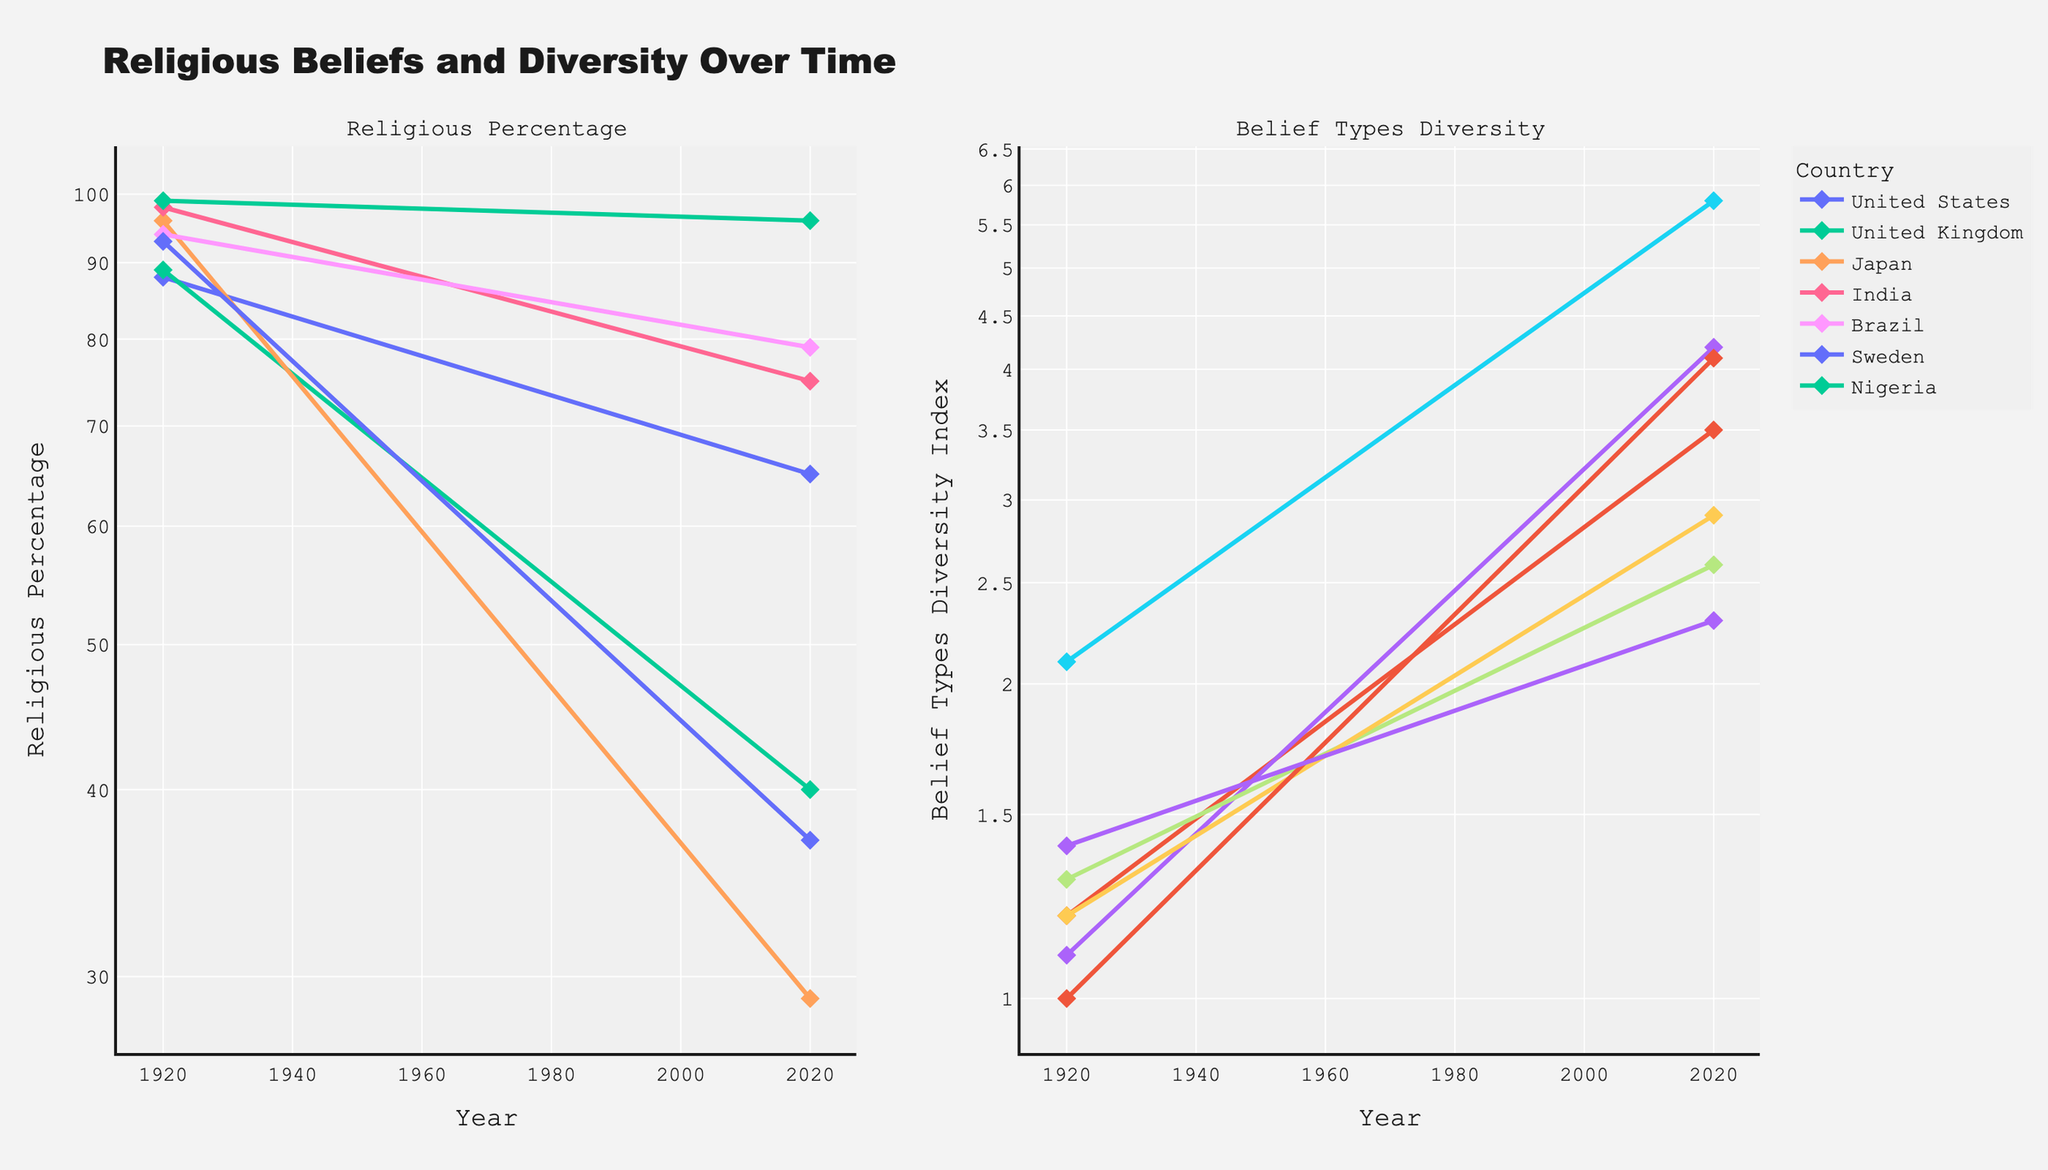Which country had the highest drop in the percentage of people who are religious from 1920 to 2020? To answer this, subtract the percentage of religious people in 2020 from that in 1920 for each country and compare the differences. For Japan: 96 - 29 = 67, United Kingdom: 89 - 40 = 49, United States: 88 - 65 = 23, Sweden: 93 - 37 = 56, India: 98 - 75 = 23, Brazil: 94 - 79 = 15, Nigeria: 99 - 96 = 3. Japan has the highest drop.
Answer: Japan Which country had the highest Belief Types Diversity Index in 2020? Simply look at the values for 2020 on the Belief Types Diversity Index subplot and identify the highest value. Japan's 2020 value is 5.8, United Kingdom: 4.2, Sweden: 4.1, United States: 3.5, Brazil: 2.9, India: 2.6, Nigeria: 2.3.
Answer: Japan What was the trend in religious percentage for the United Kingdom over the century? Observe the line trend for the United Kingdom in the Religious Percentage subplot from 1920 to 2020. The trend decreases from 89% in 1920 to 40% in 2020.
Answer: Decreasing Which country showed an increase in the Belief Types Diversity Index from 1920 to 2020 but still had one of the highest religious percentages in 2020? Look for countries with a higher Belief Types Diversity Index in 2020 compared to 1920 and significant religious percentages in 2020. Nigeria fulfills this with an index increase from 1.4 to 2.3 and religious percentage at 96%.
Answer: Nigeria How did the religious percentage of Brazil change over the period from 1920 to 2020? Look at the starting and ending points for Brazil in the Religious Percentage subplot. It decreased from 94% in 1920 to 79% in 2020.
Answer: Decreased Which country had the lowest Belief Types Diversity Index in 1920, and did it increase by 2020? Observe the values in 1920 and compare them. The lowest in 1920 was Sweden with 1.0, and by 2020, it increased to 4.1.
Answer: Sweden, yes Compare the change in the religious percentage from 1920 to 2020 between the United States and India. Which country experienced a larger decline? Subtract the 2020 values from the 1920 values for both countries: the United States (88 - 65 = 23), India (98 - 75 = 23). Both experienced an equal decline of 23%.
Answer: Equal What does the trend in the Belief Types Diversity Index suggest about Japan's religious landscape from 1920 to 2020? Analyzing Japan's Belief Types Diversity Index, you see it increased from 2.1 in 1920 to 5.8 in 2020, suggesting a significant diversification in belief types.
Answer: Diversified significantly 